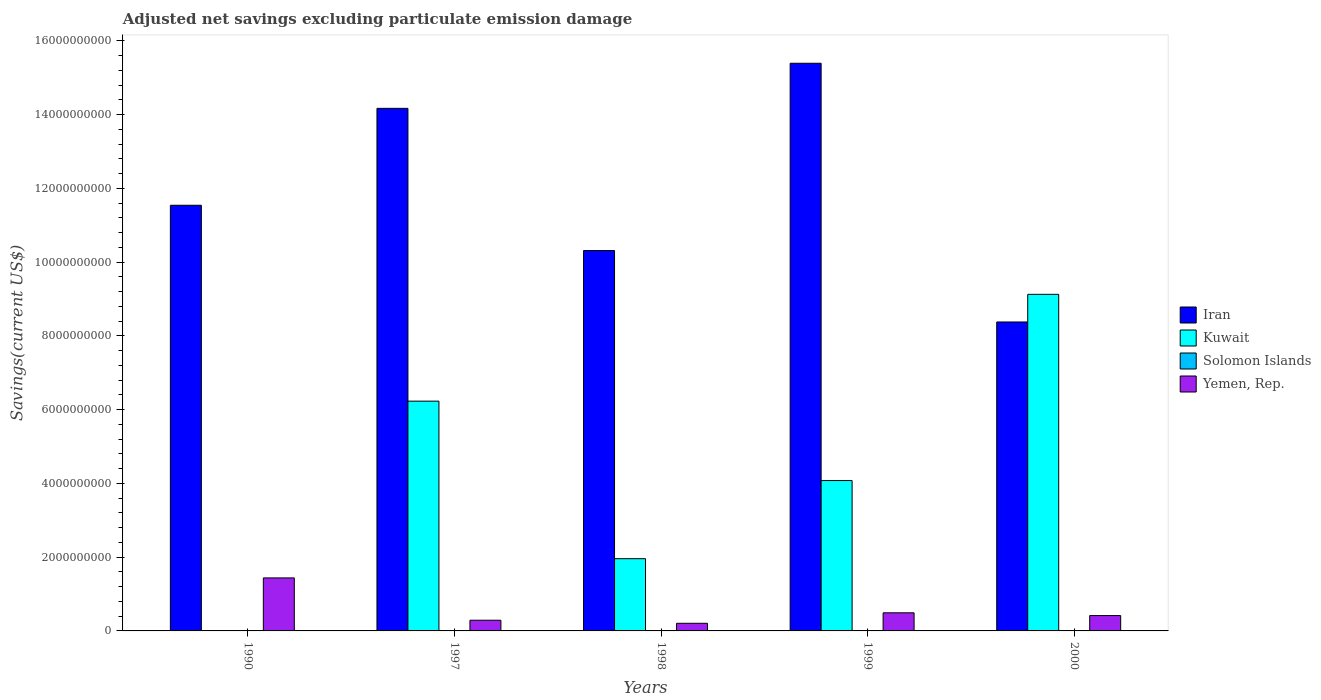Are the number of bars on each tick of the X-axis equal?
Provide a succinct answer. No. How many bars are there on the 1st tick from the left?
Give a very brief answer. 2. How many bars are there on the 5th tick from the right?
Provide a succinct answer. 2. In how many cases, is the number of bars for a given year not equal to the number of legend labels?
Offer a terse response. 5. What is the adjusted net savings in Solomon Islands in 1997?
Ensure brevity in your answer.  0. Across all years, what is the maximum adjusted net savings in Kuwait?
Your response must be concise. 9.13e+09. Across all years, what is the minimum adjusted net savings in Kuwait?
Keep it short and to the point. 0. In which year was the adjusted net savings in Iran maximum?
Offer a very short reply. 1999. What is the total adjusted net savings in Solomon Islands in the graph?
Your answer should be very brief. 0. What is the difference between the adjusted net savings in Yemen, Rep. in 1990 and that in 1997?
Your response must be concise. 1.15e+09. In the year 2000, what is the difference between the adjusted net savings in Kuwait and adjusted net savings in Yemen, Rep.?
Provide a succinct answer. 8.71e+09. What is the ratio of the adjusted net savings in Yemen, Rep. in 1990 to that in 1999?
Offer a very short reply. 2.93. Is the adjusted net savings in Yemen, Rep. in 1997 less than that in 1999?
Your answer should be compact. Yes. What is the difference between the highest and the second highest adjusted net savings in Kuwait?
Offer a very short reply. 2.90e+09. What is the difference between the highest and the lowest adjusted net savings in Yemen, Rep.?
Your response must be concise. 1.23e+09. In how many years, is the adjusted net savings in Solomon Islands greater than the average adjusted net savings in Solomon Islands taken over all years?
Your response must be concise. 0. Is the sum of the adjusted net savings in Iran in 1999 and 2000 greater than the maximum adjusted net savings in Solomon Islands across all years?
Ensure brevity in your answer.  Yes. Is it the case that in every year, the sum of the adjusted net savings in Kuwait and adjusted net savings in Solomon Islands is greater than the adjusted net savings in Iran?
Offer a very short reply. No. How many years are there in the graph?
Give a very brief answer. 5. Does the graph contain any zero values?
Ensure brevity in your answer.  Yes. Where does the legend appear in the graph?
Ensure brevity in your answer.  Center right. How many legend labels are there?
Give a very brief answer. 4. What is the title of the graph?
Provide a short and direct response. Adjusted net savings excluding particulate emission damage. What is the label or title of the Y-axis?
Your answer should be very brief. Savings(current US$). What is the Savings(current US$) in Iran in 1990?
Offer a very short reply. 1.15e+1. What is the Savings(current US$) of Yemen, Rep. in 1990?
Give a very brief answer. 1.44e+09. What is the Savings(current US$) of Iran in 1997?
Your response must be concise. 1.42e+1. What is the Savings(current US$) in Kuwait in 1997?
Provide a short and direct response. 6.23e+09. What is the Savings(current US$) in Solomon Islands in 1997?
Your response must be concise. 0. What is the Savings(current US$) of Yemen, Rep. in 1997?
Keep it short and to the point. 2.90e+08. What is the Savings(current US$) of Iran in 1998?
Provide a succinct answer. 1.03e+1. What is the Savings(current US$) in Kuwait in 1998?
Your answer should be very brief. 1.96e+09. What is the Savings(current US$) in Solomon Islands in 1998?
Ensure brevity in your answer.  0. What is the Savings(current US$) in Yemen, Rep. in 1998?
Make the answer very short. 2.07e+08. What is the Savings(current US$) of Iran in 1999?
Keep it short and to the point. 1.54e+1. What is the Savings(current US$) in Kuwait in 1999?
Offer a terse response. 4.08e+09. What is the Savings(current US$) in Yemen, Rep. in 1999?
Ensure brevity in your answer.  4.91e+08. What is the Savings(current US$) in Iran in 2000?
Provide a short and direct response. 8.38e+09. What is the Savings(current US$) of Kuwait in 2000?
Provide a short and direct response. 9.13e+09. What is the Savings(current US$) in Yemen, Rep. in 2000?
Your answer should be compact. 4.16e+08. Across all years, what is the maximum Savings(current US$) of Iran?
Your answer should be compact. 1.54e+1. Across all years, what is the maximum Savings(current US$) in Kuwait?
Give a very brief answer. 9.13e+09. Across all years, what is the maximum Savings(current US$) of Yemen, Rep.?
Make the answer very short. 1.44e+09. Across all years, what is the minimum Savings(current US$) of Iran?
Your answer should be very brief. 8.38e+09. Across all years, what is the minimum Savings(current US$) of Kuwait?
Keep it short and to the point. 0. Across all years, what is the minimum Savings(current US$) of Yemen, Rep.?
Your answer should be very brief. 2.07e+08. What is the total Savings(current US$) of Iran in the graph?
Offer a very short reply. 5.98e+1. What is the total Savings(current US$) in Kuwait in the graph?
Your answer should be very brief. 2.14e+1. What is the total Savings(current US$) of Solomon Islands in the graph?
Make the answer very short. 0. What is the total Savings(current US$) of Yemen, Rep. in the graph?
Ensure brevity in your answer.  2.84e+09. What is the difference between the Savings(current US$) of Iran in 1990 and that in 1997?
Your answer should be compact. -2.63e+09. What is the difference between the Savings(current US$) of Yemen, Rep. in 1990 and that in 1997?
Your response must be concise. 1.15e+09. What is the difference between the Savings(current US$) in Iran in 1990 and that in 1998?
Provide a short and direct response. 1.23e+09. What is the difference between the Savings(current US$) in Yemen, Rep. in 1990 and that in 1998?
Make the answer very short. 1.23e+09. What is the difference between the Savings(current US$) in Iran in 1990 and that in 1999?
Your response must be concise. -3.85e+09. What is the difference between the Savings(current US$) in Yemen, Rep. in 1990 and that in 1999?
Give a very brief answer. 9.46e+08. What is the difference between the Savings(current US$) in Iran in 1990 and that in 2000?
Make the answer very short. 3.17e+09. What is the difference between the Savings(current US$) in Yemen, Rep. in 1990 and that in 2000?
Ensure brevity in your answer.  1.02e+09. What is the difference between the Savings(current US$) of Iran in 1997 and that in 1998?
Your answer should be very brief. 3.86e+09. What is the difference between the Savings(current US$) in Kuwait in 1997 and that in 1998?
Keep it short and to the point. 4.27e+09. What is the difference between the Savings(current US$) of Yemen, Rep. in 1997 and that in 1998?
Provide a short and direct response. 8.30e+07. What is the difference between the Savings(current US$) of Iran in 1997 and that in 1999?
Offer a terse response. -1.22e+09. What is the difference between the Savings(current US$) in Kuwait in 1997 and that in 1999?
Offer a terse response. 2.15e+09. What is the difference between the Savings(current US$) in Yemen, Rep. in 1997 and that in 1999?
Your answer should be very brief. -2.01e+08. What is the difference between the Savings(current US$) in Iran in 1997 and that in 2000?
Provide a short and direct response. 5.79e+09. What is the difference between the Savings(current US$) of Kuwait in 1997 and that in 2000?
Ensure brevity in your answer.  -2.90e+09. What is the difference between the Savings(current US$) in Yemen, Rep. in 1997 and that in 2000?
Give a very brief answer. -1.26e+08. What is the difference between the Savings(current US$) of Iran in 1998 and that in 1999?
Your answer should be very brief. -5.08e+09. What is the difference between the Savings(current US$) of Kuwait in 1998 and that in 1999?
Keep it short and to the point. -2.12e+09. What is the difference between the Savings(current US$) in Yemen, Rep. in 1998 and that in 1999?
Give a very brief answer. -2.84e+08. What is the difference between the Savings(current US$) in Iran in 1998 and that in 2000?
Your answer should be compact. 1.94e+09. What is the difference between the Savings(current US$) in Kuwait in 1998 and that in 2000?
Keep it short and to the point. -7.17e+09. What is the difference between the Savings(current US$) in Yemen, Rep. in 1998 and that in 2000?
Give a very brief answer. -2.09e+08. What is the difference between the Savings(current US$) of Iran in 1999 and that in 2000?
Keep it short and to the point. 7.02e+09. What is the difference between the Savings(current US$) of Kuwait in 1999 and that in 2000?
Keep it short and to the point. -5.05e+09. What is the difference between the Savings(current US$) of Yemen, Rep. in 1999 and that in 2000?
Your answer should be compact. 7.50e+07. What is the difference between the Savings(current US$) of Iran in 1990 and the Savings(current US$) of Kuwait in 1997?
Offer a terse response. 5.31e+09. What is the difference between the Savings(current US$) in Iran in 1990 and the Savings(current US$) in Yemen, Rep. in 1997?
Keep it short and to the point. 1.13e+1. What is the difference between the Savings(current US$) of Iran in 1990 and the Savings(current US$) of Kuwait in 1998?
Keep it short and to the point. 9.58e+09. What is the difference between the Savings(current US$) in Iran in 1990 and the Savings(current US$) in Yemen, Rep. in 1998?
Ensure brevity in your answer.  1.13e+1. What is the difference between the Savings(current US$) of Iran in 1990 and the Savings(current US$) of Kuwait in 1999?
Give a very brief answer. 7.47e+09. What is the difference between the Savings(current US$) in Iran in 1990 and the Savings(current US$) in Yemen, Rep. in 1999?
Make the answer very short. 1.11e+1. What is the difference between the Savings(current US$) in Iran in 1990 and the Savings(current US$) in Kuwait in 2000?
Offer a very short reply. 2.42e+09. What is the difference between the Savings(current US$) in Iran in 1990 and the Savings(current US$) in Yemen, Rep. in 2000?
Offer a very short reply. 1.11e+1. What is the difference between the Savings(current US$) of Iran in 1997 and the Savings(current US$) of Kuwait in 1998?
Offer a very short reply. 1.22e+1. What is the difference between the Savings(current US$) of Iran in 1997 and the Savings(current US$) of Yemen, Rep. in 1998?
Make the answer very short. 1.40e+1. What is the difference between the Savings(current US$) in Kuwait in 1997 and the Savings(current US$) in Yemen, Rep. in 1998?
Provide a short and direct response. 6.02e+09. What is the difference between the Savings(current US$) in Iran in 1997 and the Savings(current US$) in Kuwait in 1999?
Provide a succinct answer. 1.01e+1. What is the difference between the Savings(current US$) in Iran in 1997 and the Savings(current US$) in Yemen, Rep. in 1999?
Provide a short and direct response. 1.37e+1. What is the difference between the Savings(current US$) in Kuwait in 1997 and the Savings(current US$) in Yemen, Rep. in 1999?
Ensure brevity in your answer.  5.74e+09. What is the difference between the Savings(current US$) of Iran in 1997 and the Savings(current US$) of Kuwait in 2000?
Keep it short and to the point. 5.04e+09. What is the difference between the Savings(current US$) in Iran in 1997 and the Savings(current US$) in Yemen, Rep. in 2000?
Your answer should be very brief. 1.38e+1. What is the difference between the Savings(current US$) in Kuwait in 1997 and the Savings(current US$) in Yemen, Rep. in 2000?
Ensure brevity in your answer.  5.81e+09. What is the difference between the Savings(current US$) in Iran in 1998 and the Savings(current US$) in Kuwait in 1999?
Give a very brief answer. 6.24e+09. What is the difference between the Savings(current US$) of Iran in 1998 and the Savings(current US$) of Yemen, Rep. in 1999?
Your answer should be very brief. 9.82e+09. What is the difference between the Savings(current US$) in Kuwait in 1998 and the Savings(current US$) in Yemen, Rep. in 1999?
Offer a terse response. 1.47e+09. What is the difference between the Savings(current US$) in Iran in 1998 and the Savings(current US$) in Kuwait in 2000?
Give a very brief answer. 1.19e+09. What is the difference between the Savings(current US$) of Iran in 1998 and the Savings(current US$) of Yemen, Rep. in 2000?
Provide a succinct answer. 9.90e+09. What is the difference between the Savings(current US$) in Kuwait in 1998 and the Savings(current US$) in Yemen, Rep. in 2000?
Offer a very short reply. 1.54e+09. What is the difference between the Savings(current US$) of Iran in 1999 and the Savings(current US$) of Kuwait in 2000?
Offer a very short reply. 6.27e+09. What is the difference between the Savings(current US$) of Iran in 1999 and the Savings(current US$) of Yemen, Rep. in 2000?
Your answer should be compact. 1.50e+1. What is the difference between the Savings(current US$) of Kuwait in 1999 and the Savings(current US$) of Yemen, Rep. in 2000?
Keep it short and to the point. 3.66e+09. What is the average Savings(current US$) in Iran per year?
Keep it short and to the point. 1.20e+1. What is the average Savings(current US$) of Kuwait per year?
Your response must be concise. 4.28e+09. What is the average Savings(current US$) in Solomon Islands per year?
Ensure brevity in your answer.  0. What is the average Savings(current US$) of Yemen, Rep. per year?
Provide a short and direct response. 5.68e+08. In the year 1990, what is the difference between the Savings(current US$) of Iran and Savings(current US$) of Yemen, Rep.?
Your answer should be compact. 1.01e+1. In the year 1997, what is the difference between the Savings(current US$) in Iran and Savings(current US$) in Kuwait?
Offer a very short reply. 7.94e+09. In the year 1997, what is the difference between the Savings(current US$) of Iran and Savings(current US$) of Yemen, Rep.?
Provide a succinct answer. 1.39e+1. In the year 1997, what is the difference between the Savings(current US$) of Kuwait and Savings(current US$) of Yemen, Rep.?
Your answer should be compact. 5.94e+09. In the year 1998, what is the difference between the Savings(current US$) in Iran and Savings(current US$) in Kuwait?
Keep it short and to the point. 8.36e+09. In the year 1998, what is the difference between the Savings(current US$) in Iran and Savings(current US$) in Yemen, Rep.?
Your answer should be very brief. 1.01e+1. In the year 1998, what is the difference between the Savings(current US$) of Kuwait and Savings(current US$) of Yemen, Rep.?
Offer a very short reply. 1.75e+09. In the year 1999, what is the difference between the Savings(current US$) in Iran and Savings(current US$) in Kuwait?
Give a very brief answer. 1.13e+1. In the year 1999, what is the difference between the Savings(current US$) in Iran and Savings(current US$) in Yemen, Rep.?
Offer a terse response. 1.49e+1. In the year 1999, what is the difference between the Savings(current US$) in Kuwait and Savings(current US$) in Yemen, Rep.?
Provide a short and direct response. 3.59e+09. In the year 2000, what is the difference between the Savings(current US$) in Iran and Savings(current US$) in Kuwait?
Your response must be concise. -7.50e+08. In the year 2000, what is the difference between the Savings(current US$) in Iran and Savings(current US$) in Yemen, Rep.?
Ensure brevity in your answer.  7.96e+09. In the year 2000, what is the difference between the Savings(current US$) of Kuwait and Savings(current US$) of Yemen, Rep.?
Offer a very short reply. 8.71e+09. What is the ratio of the Savings(current US$) of Iran in 1990 to that in 1997?
Offer a terse response. 0.81. What is the ratio of the Savings(current US$) of Yemen, Rep. in 1990 to that in 1997?
Your answer should be very brief. 4.96. What is the ratio of the Savings(current US$) of Iran in 1990 to that in 1998?
Provide a succinct answer. 1.12. What is the ratio of the Savings(current US$) of Yemen, Rep. in 1990 to that in 1998?
Your response must be concise. 6.94. What is the ratio of the Savings(current US$) in Iran in 1990 to that in 1999?
Ensure brevity in your answer.  0.75. What is the ratio of the Savings(current US$) in Yemen, Rep. in 1990 to that in 1999?
Offer a terse response. 2.93. What is the ratio of the Savings(current US$) of Iran in 1990 to that in 2000?
Provide a succinct answer. 1.38. What is the ratio of the Savings(current US$) in Yemen, Rep. in 1990 to that in 2000?
Your response must be concise. 3.45. What is the ratio of the Savings(current US$) in Iran in 1997 to that in 1998?
Make the answer very short. 1.37. What is the ratio of the Savings(current US$) in Kuwait in 1997 to that in 1998?
Make the answer very short. 3.18. What is the ratio of the Savings(current US$) in Yemen, Rep. in 1997 to that in 1998?
Your answer should be very brief. 1.4. What is the ratio of the Savings(current US$) in Iran in 1997 to that in 1999?
Your answer should be compact. 0.92. What is the ratio of the Savings(current US$) in Kuwait in 1997 to that in 1999?
Give a very brief answer. 1.53. What is the ratio of the Savings(current US$) of Yemen, Rep. in 1997 to that in 1999?
Provide a succinct answer. 0.59. What is the ratio of the Savings(current US$) of Iran in 1997 to that in 2000?
Ensure brevity in your answer.  1.69. What is the ratio of the Savings(current US$) of Kuwait in 1997 to that in 2000?
Give a very brief answer. 0.68. What is the ratio of the Savings(current US$) in Yemen, Rep. in 1997 to that in 2000?
Offer a very short reply. 0.7. What is the ratio of the Savings(current US$) of Iran in 1998 to that in 1999?
Offer a terse response. 0.67. What is the ratio of the Savings(current US$) of Kuwait in 1998 to that in 1999?
Offer a very short reply. 0.48. What is the ratio of the Savings(current US$) in Yemen, Rep. in 1998 to that in 1999?
Ensure brevity in your answer.  0.42. What is the ratio of the Savings(current US$) in Iran in 1998 to that in 2000?
Offer a terse response. 1.23. What is the ratio of the Savings(current US$) of Kuwait in 1998 to that in 2000?
Provide a short and direct response. 0.21. What is the ratio of the Savings(current US$) in Yemen, Rep. in 1998 to that in 2000?
Make the answer very short. 0.5. What is the ratio of the Savings(current US$) in Iran in 1999 to that in 2000?
Make the answer very short. 1.84. What is the ratio of the Savings(current US$) of Kuwait in 1999 to that in 2000?
Make the answer very short. 0.45. What is the ratio of the Savings(current US$) in Yemen, Rep. in 1999 to that in 2000?
Give a very brief answer. 1.18. What is the difference between the highest and the second highest Savings(current US$) of Iran?
Your response must be concise. 1.22e+09. What is the difference between the highest and the second highest Savings(current US$) of Kuwait?
Give a very brief answer. 2.90e+09. What is the difference between the highest and the second highest Savings(current US$) of Yemen, Rep.?
Offer a very short reply. 9.46e+08. What is the difference between the highest and the lowest Savings(current US$) of Iran?
Your response must be concise. 7.02e+09. What is the difference between the highest and the lowest Savings(current US$) of Kuwait?
Your response must be concise. 9.13e+09. What is the difference between the highest and the lowest Savings(current US$) of Yemen, Rep.?
Your response must be concise. 1.23e+09. 